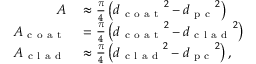<formula> <loc_0><loc_0><loc_500><loc_500>\begin{array} { r l } { A } & \approx \frac { \pi } { 4 } \left ( { d _ { c o a t } } ^ { 2 } - { d _ { p c } } ^ { 2 } \right ) } \\ { A _ { c o a t } } & = \frac { \pi } { 4 } \left ( { d _ { c o a t } } ^ { 2 } - { d _ { c l a d } } ^ { 2 } \right ) } \\ { A _ { c l a d } } & \approx \frac { \pi } { 4 } \left ( { d _ { c l a d } } ^ { 2 } - { d _ { p c } } ^ { 2 } \right ) , } \end{array}</formula> 